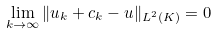<formula> <loc_0><loc_0><loc_500><loc_500>\lim _ { k \to \infty } \| u _ { k } + c _ { k } - u \| _ { L ^ { 2 } ( K ) } = 0</formula> 